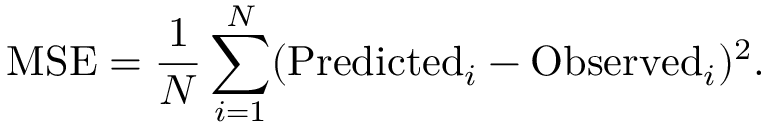Convert formula to latex. <formula><loc_0><loc_0><loc_500><loc_500>M S E = \frac { 1 } { N } \sum _ { i = 1 } ^ { N } ( P r e d i c t e d _ { i } - O b s e r v e d _ { i } ) ^ { 2 } .</formula> 